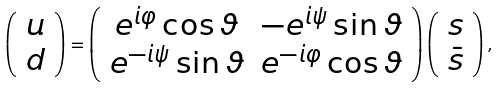<formula> <loc_0><loc_0><loc_500><loc_500>\left ( \begin{array} { c } u \\ d \end{array} \right ) = \left ( \begin{array} { c c } e ^ { i \varphi } \cos \vartheta & - e ^ { i \psi } \sin \vartheta \\ e ^ { - i \psi } \sin \vartheta & e ^ { - i \varphi } \cos \vartheta \end{array} \right ) \left ( \begin{array} { c } s \\ \bar { s } \end{array} \right ) ,</formula> 